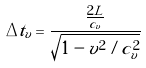<formula> <loc_0><loc_0><loc_500><loc_500>\Delta t _ { v } = \frac { \frac { 2 L } { c _ { v } } } { \sqrt { 1 - v ^ { 2 } / c _ { v } ^ { 2 } } }</formula> 